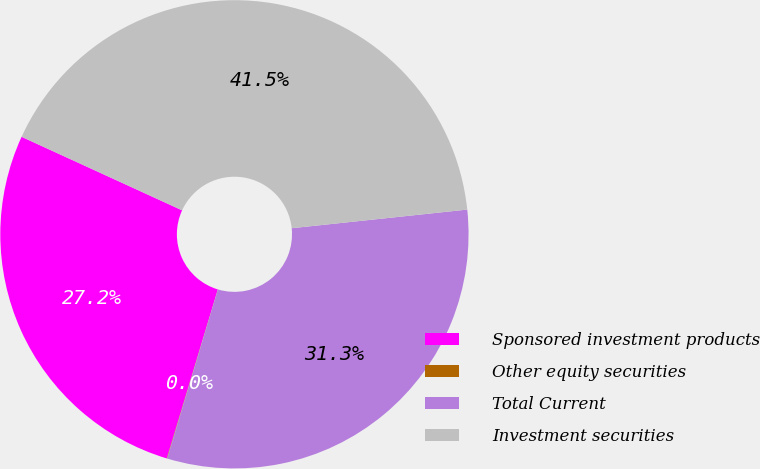Convert chart. <chart><loc_0><loc_0><loc_500><loc_500><pie_chart><fcel>Sponsored investment products<fcel>Other equity securities<fcel>Total Current<fcel>Investment securities<nl><fcel>27.17%<fcel>0.03%<fcel>31.32%<fcel>41.48%<nl></chart> 